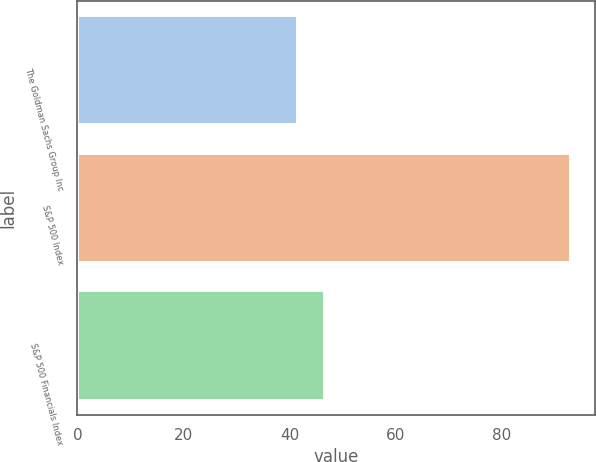Convert chart to OTSL. <chart><loc_0><loc_0><loc_500><loc_500><bar_chart><fcel>The Goldman Sachs Group Inc<fcel>S&P 500 Index<fcel>S&P 500 Financials Index<nl><fcel>41.61<fcel>92.96<fcel>46.74<nl></chart> 